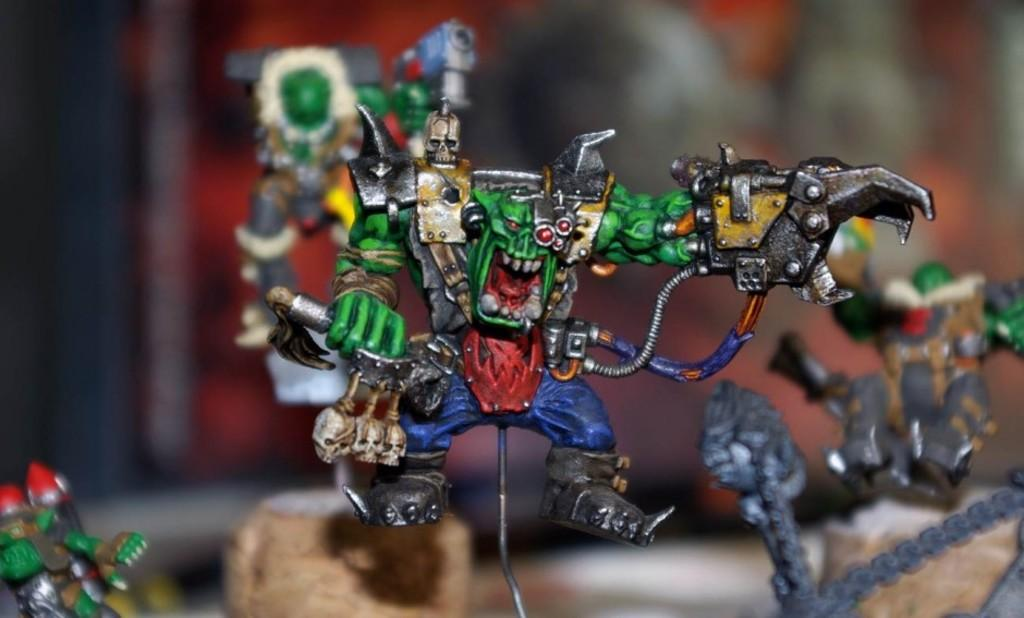What objects can be seen in the image? There are toys in the image. Can you describe the background of the image? The background of the image is blurry. What type of hate can be seen expressed through the toys in the image? There is no hate expressed through the toys in the image, as they are inanimate objects. 